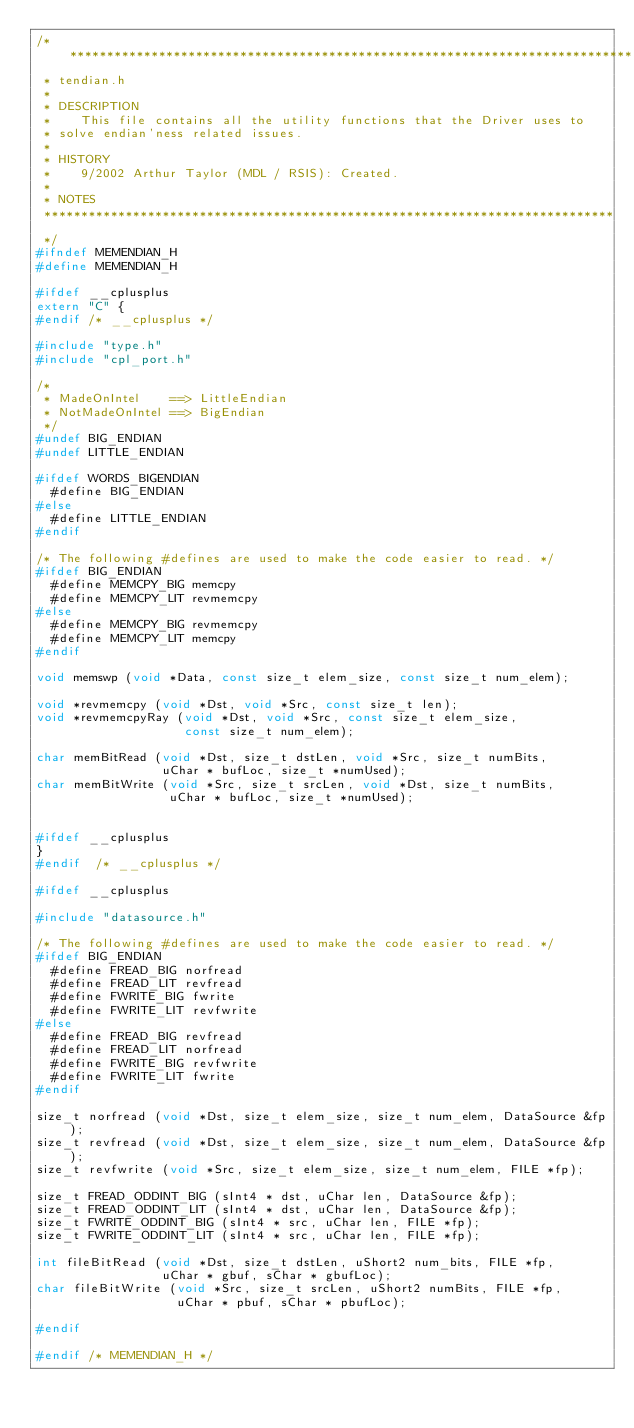<code> <loc_0><loc_0><loc_500><loc_500><_C_>/*****************************************************************************
 * tendian.h
 *
 * DESCRIPTION
 *    This file contains all the utility functions that the Driver uses to
 * solve endian'ness related issues.
 *
 * HISTORY
 *    9/2002 Arthur Taylor (MDL / RSIS): Created.
 *
 * NOTES
 *****************************************************************************
 */
#ifndef MEMENDIAN_H
#define MEMENDIAN_H

#ifdef __cplusplus
extern "C" {
#endif /* __cplusplus */

#include "type.h"
#include "cpl_port.h"

/*
 * MadeOnIntel    ==> LittleEndian
 * NotMadeOnIntel ==> BigEndian
 */
#undef BIG_ENDIAN
#undef LITTLE_ENDIAN

#ifdef WORDS_BIGENDIAN
  #define BIG_ENDIAN
#else
  #define LITTLE_ENDIAN
#endif

/* The following #defines are used to make the code easier to read. */
#ifdef BIG_ENDIAN
  #define MEMCPY_BIG memcpy
  #define MEMCPY_LIT revmemcpy
#else
  #define MEMCPY_BIG revmemcpy
  #define MEMCPY_LIT memcpy
#endif

void memswp (void *Data, const size_t elem_size, const size_t num_elem);

void *revmemcpy (void *Dst, void *Src, const size_t len);
void *revmemcpyRay (void *Dst, void *Src, const size_t elem_size,
                    const size_t num_elem);

char memBitRead (void *Dst, size_t dstLen, void *Src, size_t numBits,
                 uChar * bufLoc, size_t *numUsed);
char memBitWrite (void *Src, size_t srcLen, void *Dst, size_t numBits,
                  uChar * bufLoc, size_t *numUsed);


#ifdef __cplusplus
}
#endif  /* __cplusplus */

#ifdef __cplusplus

#include "datasource.h"

/* The following #defines are used to make the code easier to read. */
#ifdef BIG_ENDIAN
  #define FREAD_BIG norfread
  #define FREAD_LIT revfread
  #define FWRITE_BIG fwrite
  #define FWRITE_LIT revfwrite
#else
  #define FREAD_BIG revfread
  #define FREAD_LIT norfread
  #define FWRITE_BIG revfwrite
  #define FWRITE_LIT fwrite
#endif

size_t norfread (void *Dst, size_t elem_size, size_t num_elem, DataSource &fp);
size_t revfread (void *Dst, size_t elem_size, size_t num_elem, DataSource &fp);
size_t revfwrite (void *Src, size_t elem_size, size_t num_elem, FILE *fp);

size_t FREAD_ODDINT_BIG (sInt4 * dst, uChar len, DataSource &fp);
size_t FREAD_ODDINT_LIT (sInt4 * dst, uChar len, DataSource &fp);
size_t FWRITE_ODDINT_BIG (sInt4 * src, uChar len, FILE *fp);
size_t FWRITE_ODDINT_LIT (sInt4 * src, uChar len, FILE *fp);

int fileBitRead (void *Dst, size_t dstLen, uShort2 num_bits, FILE *fp,
                 uChar * gbuf, sChar * gbufLoc);
char fileBitWrite (void *Src, size_t srcLen, uShort2 numBits, FILE *fp,
                   uChar * pbuf, sChar * pbufLoc);

#endif

#endif /* MEMENDIAN_H */
</code> 